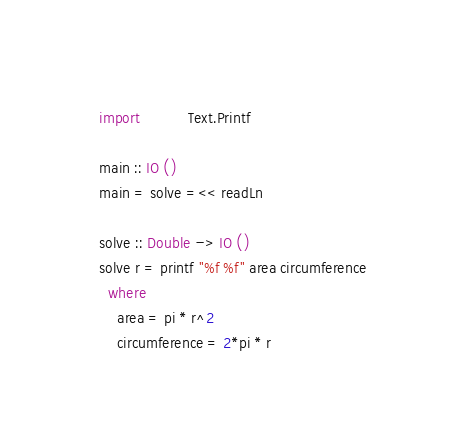<code> <loc_0><loc_0><loc_500><loc_500><_Haskell_>import           Text.Printf

main :: IO ()
main = solve =<< readLn

solve :: Double -> IO ()
solve r = printf "%f %f" area circumference
  where
    area = pi * r^2
    circumference = 2*pi * r

</code> 